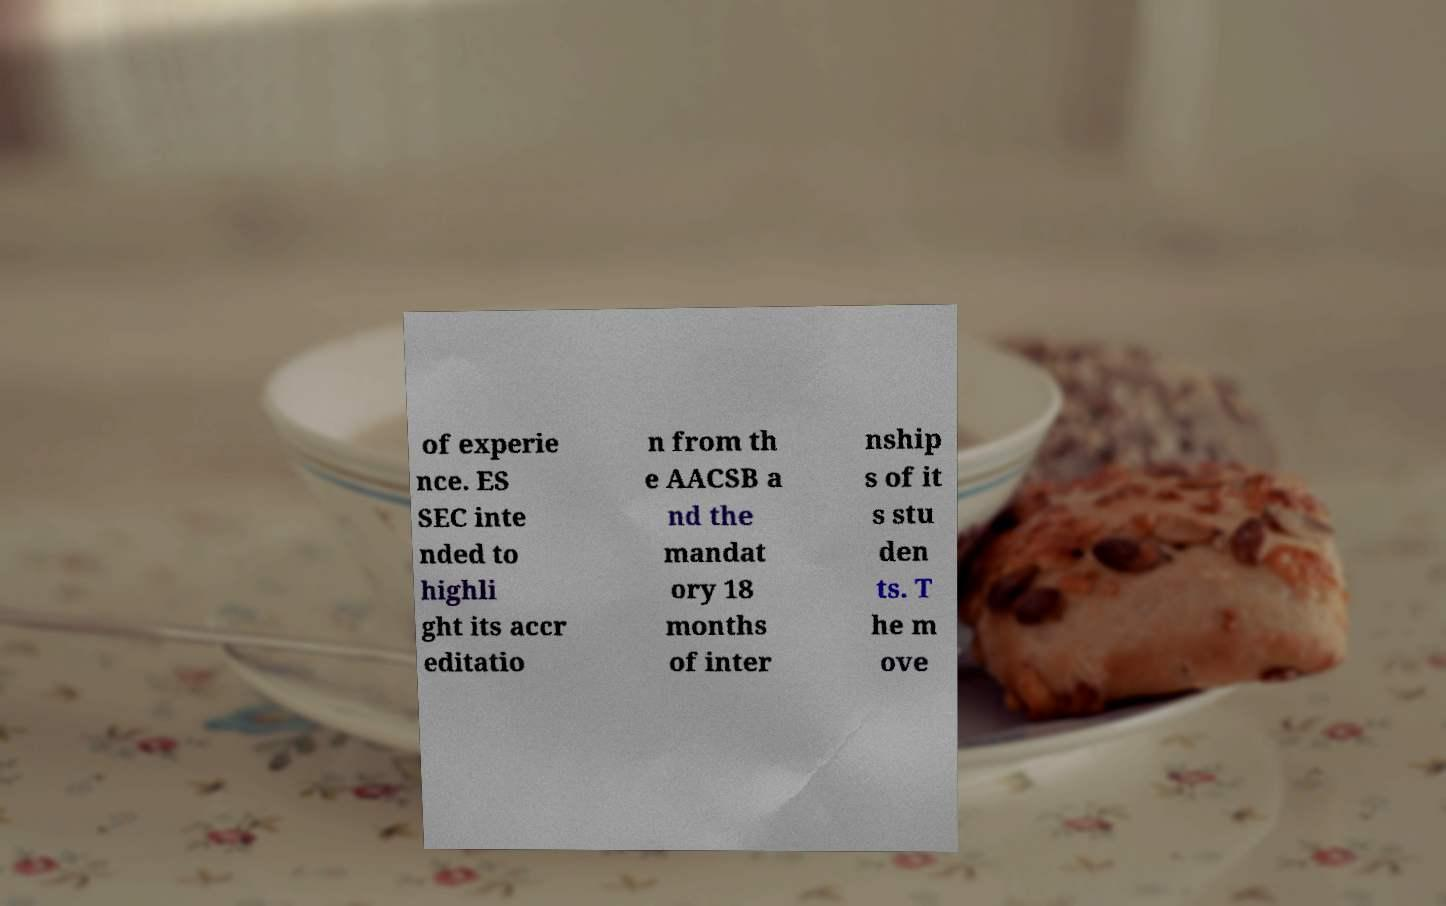There's text embedded in this image that I need extracted. Can you transcribe it verbatim? of experie nce. ES SEC inte nded to highli ght its accr editatio n from th e AACSB a nd the mandat ory 18 months of inter nship s of it s stu den ts. T he m ove 